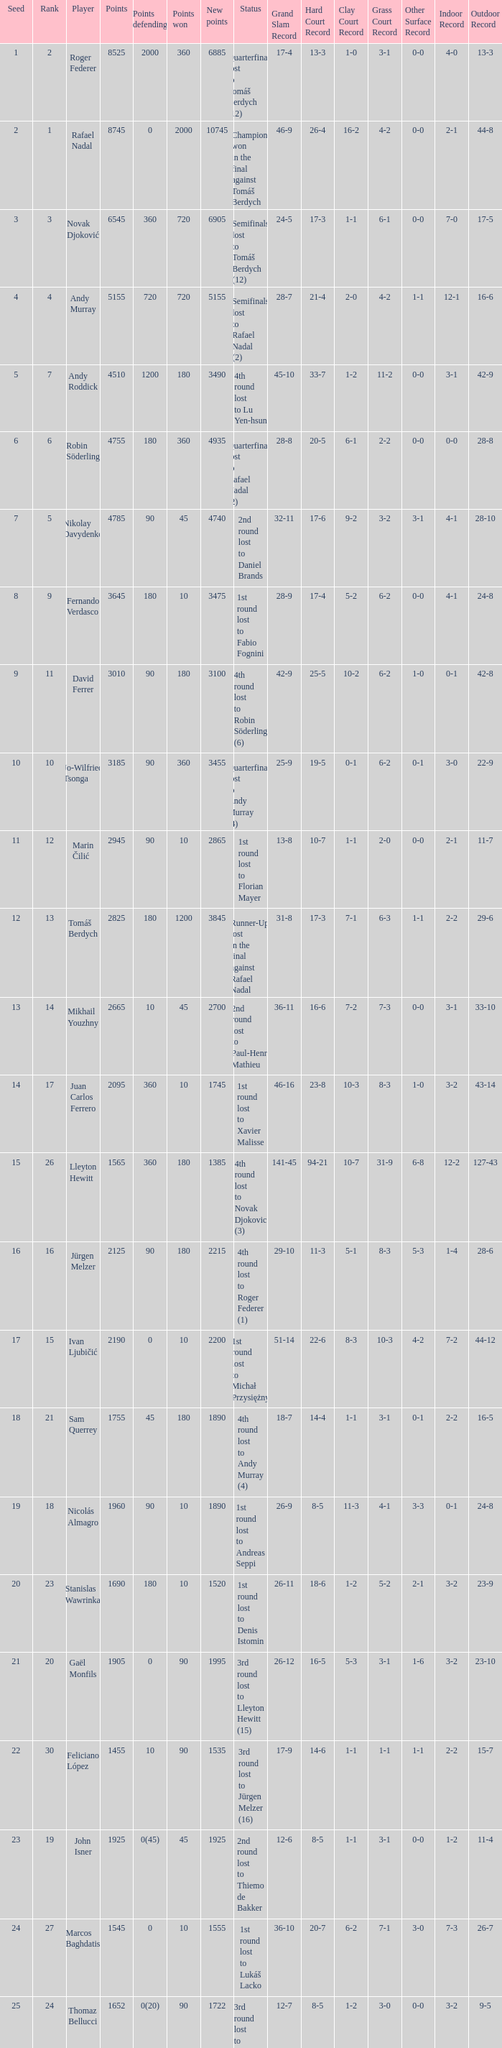Specify the points earned for 1230 90.0. 